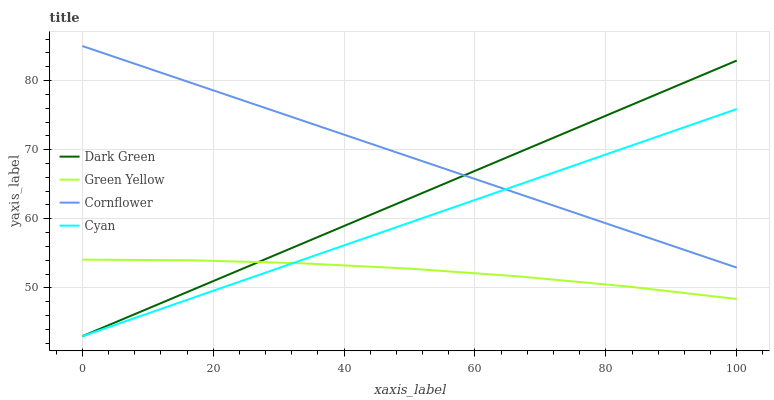Does Green Yellow have the minimum area under the curve?
Answer yes or no. Yes. Does Cornflower have the maximum area under the curve?
Answer yes or no. Yes. Does Cyan have the minimum area under the curve?
Answer yes or no. No. Does Cyan have the maximum area under the curve?
Answer yes or no. No. Is Dark Green the smoothest?
Answer yes or no. Yes. Is Green Yellow the roughest?
Answer yes or no. Yes. Is Cyan the smoothest?
Answer yes or no. No. Is Cyan the roughest?
Answer yes or no. No. Does Cyan have the lowest value?
Answer yes or no. Yes. Does Green Yellow have the lowest value?
Answer yes or no. No. Does Cornflower have the highest value?
Answer yes or no. Yes. Does Cyan have the highest value?
Answer yes or no. No. Is Green Yellow less than Cornflower?
Answer yes or no. Yes. Is Cornflower greater than Green Yellow?
Answer yes or no. Yes. Does Green Yellow intersect Dark Green?
Answer yes or no. Yes. Is Green Yellow less than Dark Green?
Answer yes or no. No. Is Green Yellow greater than Dark Green?
Answer yes or no. No. Does Green Yellow intersect Cornflower?
Answer yes or no. No. 